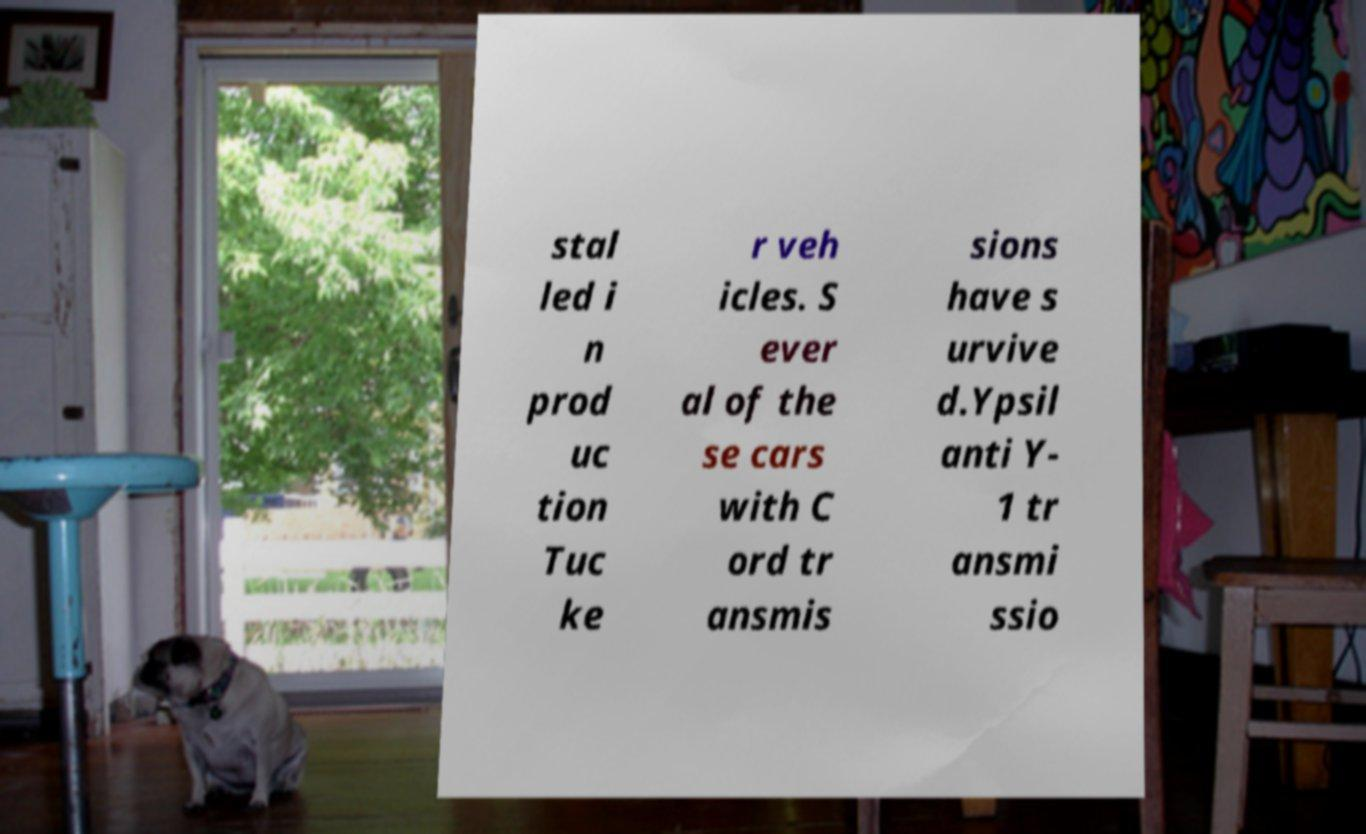Could you extract and type out the text from this image? stal led i n prod uc tion Tuc ke r veh icles. S ever al of the se cars with C ord tr ansmis sions have s urvive d.Ypsil anti Y- 1 tr ansmi ssio 